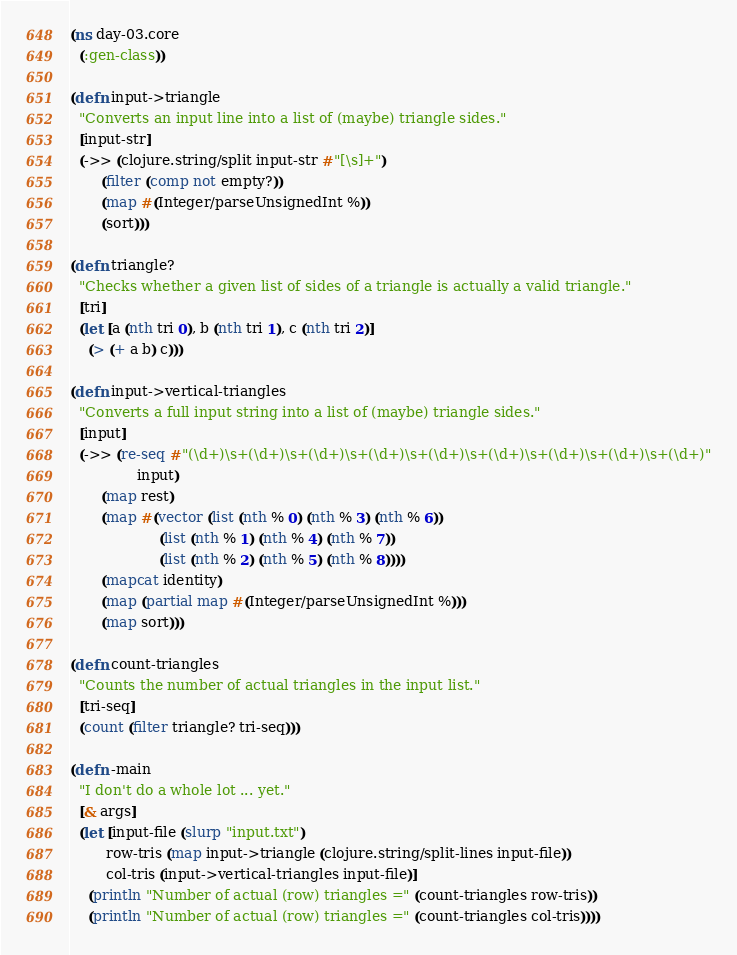<code> <loc_0><loc_0><loc_500><loc_500><_Clojure_>(ns day-03.core
  (:gen-class))

(defn input->triangle
  "Converts an input line into a list of (maybe) triangle sides."
  [input-str]
  (->> (clojure.string/split input-str #"[\s]+")
       (filter (comp not empty?))
       (map #(Integer/parseUnsignedInt %))
       (sort)))

(defn triangle?
  "Checks whether a given list of sides of a triangle is actually a valid triangle."
  [tri]
  (let [a (nth tri 0), b (nth tri 1), c (nth tri 2)]
    (> (+ a b) c)))

(defn input->vertical-triangles
  "Converts a full input string into a list of (maybe) triangle sides."
  [input]
  (->> (re-seq #"(\d+)\s+(\d+)\s+(\d+)\s+(\d+)\s+(\d+)\s+(\d+)\s+(\d+)\s+(\d+)\s+(\d+)"
               input)
       (map rest)
       (map #(vector (list (nth % 0) (nth % 3) (nth % 6))
                    (list (nth % 1) (nth % 4) (nth % 7))
                    (list (nth % 2) (nth % 5) (nth % 8))))
       (mapcat identity)
       (map (partial map #(Integer/parseUnsignedInt %)))
       (map sort)))

(defn count-triangles
  "Counts the number of actual triangles in the input list."
  [tri-seq]
  (count (filter triangle? tri-seq)))

(defn -main
  "I don't do a whole lot ... yet."
  [& args]
  (let [input-file (slurp "input.txt")
        row-tris (map input->triangle (clojure.string/split-lines input-file))
        col-tris (input->vertical-triangles input-file)]
    (println "Number of actual (row) triangles =" (count-triangles row-tris))
    (println "Number of actual (row) triangles =" (count-triangles col-tris))))
</code> 